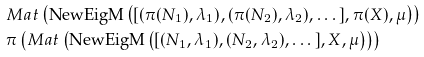Convert formula to latex. <formula><loc_0><loc_0><loc_500><loc_500>& M a t \left ( \text {NewEigM} \left ( [ ( \pi ( N _ { 1 } ) , \lambda _ { 1 } ) , ( \pi ( N _ { 2 } ) , \lambda _ { 2 } ) , \dots ] , \pi ( X ) , \mu \right ) \right ) \\ & \pi \left ( M a t \left ( \text {NewEigM} \left ( [ ( N _ { 1 } , \lambda _ { 1 } ) , ( N _ { 2 } , \lambda _ { 2 } ) , \dots ] , X , \mu \right ) \right ) \right )</formula> 